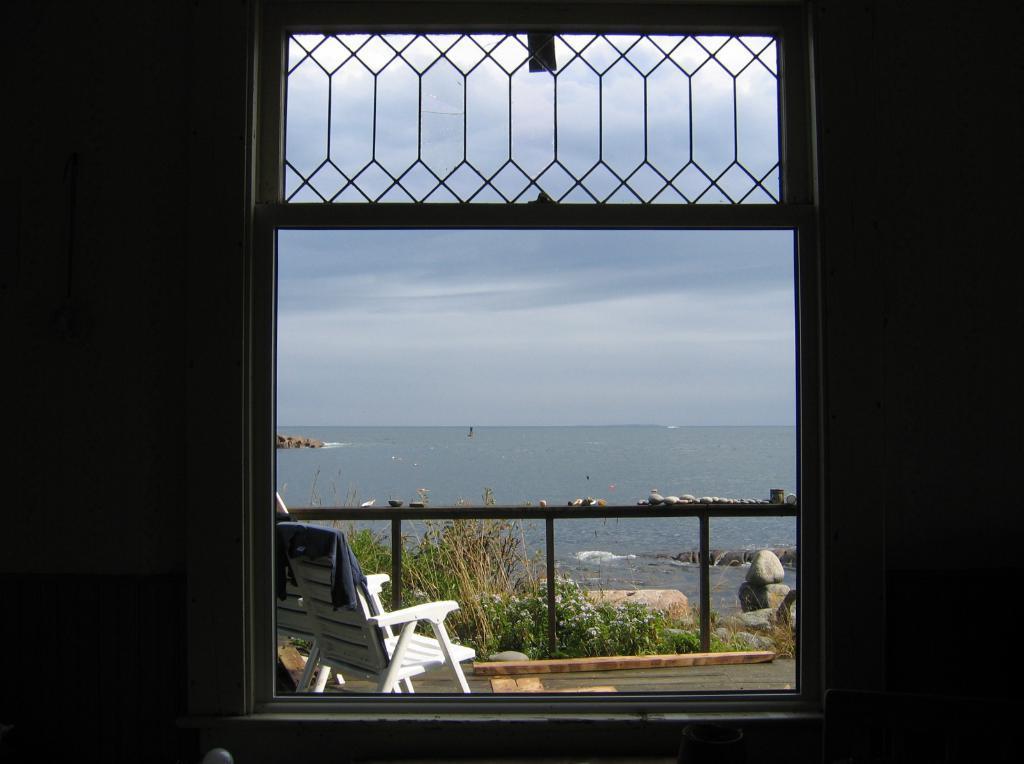Can you describe this image briefly? It is a window, outside this there is a chair which is in white color and this is water, at the top it's a sky. 